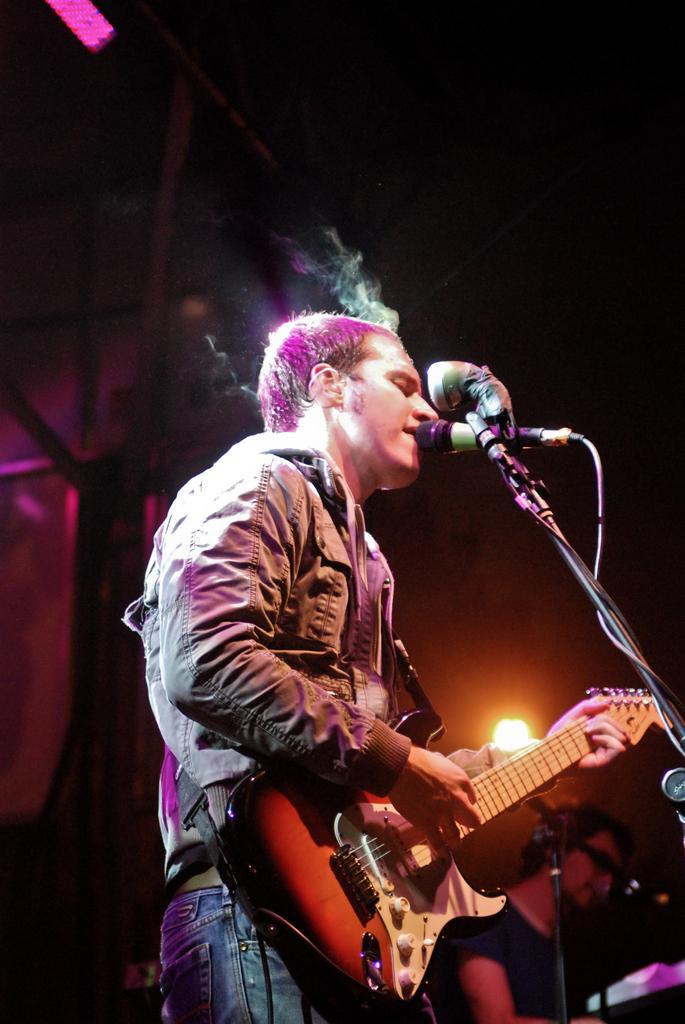Could you give a brief overview of what you see in this image? This picture shows a man is playing guitar in front of microphone, in the background we can see light. 